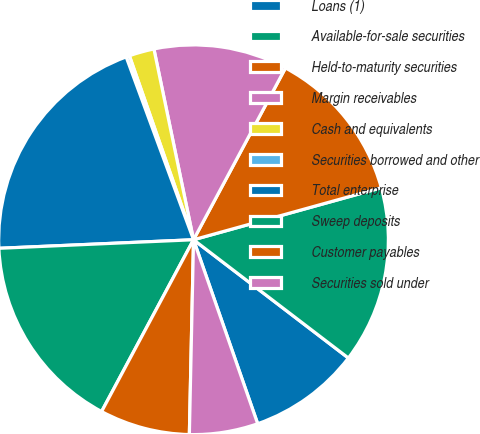<chart> <loc_0><loc_0><loc_500><loc_500><pie_chart><fcel>Loans (1)<fcel>Available-for-sale securities<fcel>Held-to-maturity securities<fcel>Margin receivables<fcel>Cash and equivalents<fcel>Securities borrowed and other<fcel>Total enterprise<fcel>Sweep deposits<fcel>Customer payables<fcel>Securities sold under<nl><fcel>9.28%<fcel>14.68%<fcel>12.88%<fcel>11.08%<fcel>2.08%<fcel>0.28%<fcel>20.08%<fcel>16.48%<fcel>7.48%<fcel>5.68%<nl></chart> 